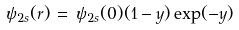Convert formula to latex. <formula><loc_0><loc_0><loc_500><loc_500>\psi _ { 2 s } ( r ) \, = \, \psi _ { 2 s } ( 0 ) ( 1 - y ) \exp ( - y )</formula> 